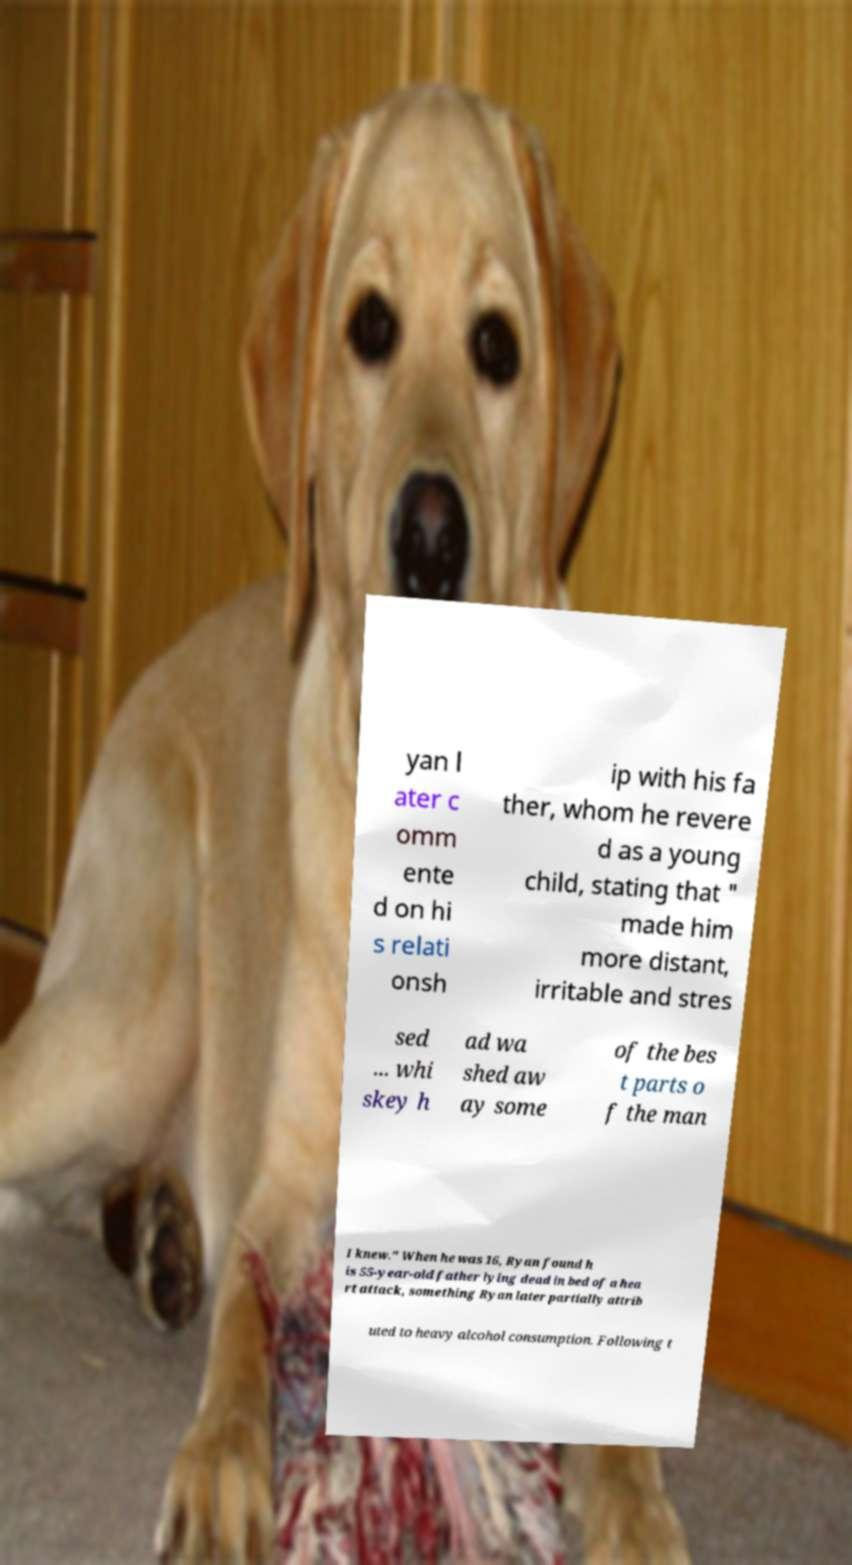Please identify and transcribe the text found in this image. yan l ater c omm ente d on hi s relati onsh ip with his fa ther, whom he revere d as a young child, stating that " made him more distant, irritable and stres sed ... whi skey h ad wa shed aw ay some of the bes t parts o f the man I knew." When he was 16, Ryan found h is 55-year-old father lying dead in bed of a hea rt attack, something Ryan later partially attrib uted to heavy alcohol consumption. Following t 